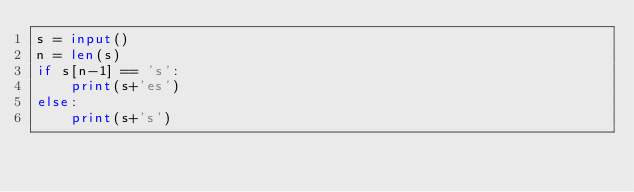Convert code to text. <code><loc_0><loc_0><loc_500><loc_500><_Python_>s = input()
n = len(s)
if s[n-1] == 's':
    print(s+'es')
else:
    print(s+'s')</code> 